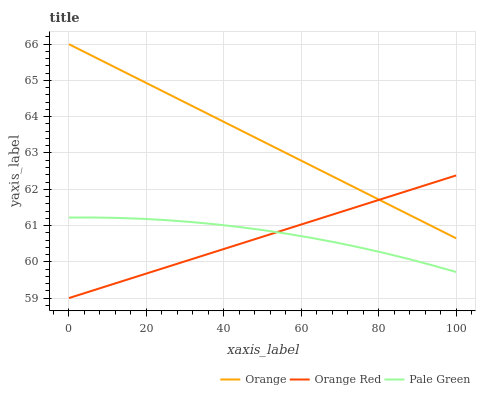Does Orange Red have the minimum area under the curve?
Answer yes or no. Yes. Does Orange have the maximum area under the curve?
Answer yes or no. Yes. Does Pale Green have the minimum area under the curve?
Answer yes or no. No. Does Pale Green have the maximum area under the curve?
Answer yes or no. No. Is Orange Red the smoothest?
Answer yes or no. Yes. Is Pale Green the roughest?
Answer yes or no. Yes. Is Pale Green the smoothest?
Answer yes or no. No. Is Orange Red the roughest?
Answer yes or no. No. Does Orange Red have the lowest value?
Answer yes or no. Yes. Does Pale Green have the lowest value?
Answer yes or no. No. Does Orange have the highest value?
Answer yes or no. Yes. Does Orange Red have the highest value?
Answer yes or no. No. Is Pale Green less than Orange?
Answer yes or no. Yes. Is Orange greater than Pale Green?
Answer yes or no. Yes. Does Orange Red intersect Pale Green?
Answer yes or no. Yes. Is Orange Red less than Pale Green?
Answer yes or no. No. Is Orange Red greater than Pale Green?
Answer yes or no. No. Does Pale Green intersect Orange?
Answer yes or no. No. 